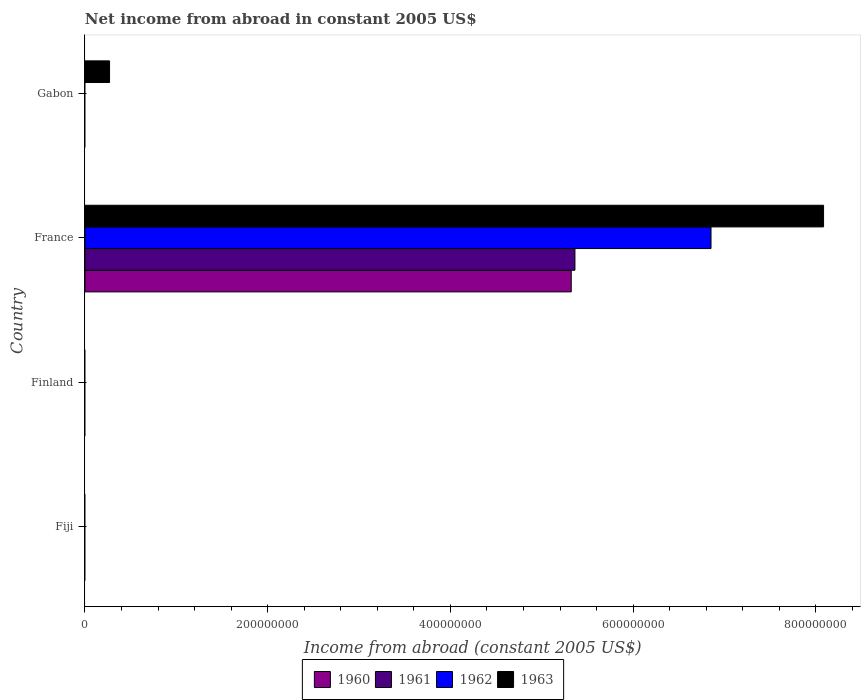Are the number of bars per tick equal to the number of legend labels?
Your answer should be compact. No. Are the number of bars on each tick of the Y-axis equal?
Keep it short and to the point. No. What is the label of the 1st group of bars from the top?
Provide a short and direct response. Gabon. In how many cases, is the number of bars for a given country not equal to the number of legend labels?
Offer a terse response. 3. What is the net income from abroad in 1962 in France?
Make the answer very short. 6.85e+08. Across all countries, what is the maximum net income from abroad in 1962?
Your response must be concise. 6.85e+08. Across all countries, what is the minimum net income from abroad in 1960?
Offer a very short reply. 0. What is the total net income from abroad in 1963 in the graph?
Provide a succinct answer. 8.35e+08. What is the difference between the net income from abroad in 1963 in France and that in Gabon?
Your answer should be compact. 7.81e+08. What is the difference between the net income from abroad in 1963 in Fiji and the net income from abroad in 1961 in Gabon?
Give a very brief answer. 0. What is the average net income from abroad in 1962 per country?
Provide a short and direct response. 1.71e+08. What is the difference between the net income from abroad in 1960 and net income from abroad in 1962 in France?
Provide a short and direct response. -1.53e+08. What is the difference between the highest and the lowest net income from abroad in 1963?
Give a very brief answer. 8.08e+08. Are all the bars in the graph horizontal?
Your answer should be compact. Yes. What is the difference between two consecutive major ticks on the X-axis?
Provide a succinct answer. 2.00e+08. Are the values on the major ticks of X-axis written in scientific E-notation?
Offer a very short reply. No. Does the graph contain grids?
Provide a short and direct response. No. Where does the legend appear in the graph?
Your response must be concise. Bottom center. How many legend labels are there?
Your answer should be compact. 4. How are the legend labels stacked?
Offer a terse response. Horizontal. What is the title of the graph?
Ensure brevity in your answer.  Net income from abroad in constant 2005 US$. Does "1991" appear as one of the legend labels in the graph?
Provide a short and direct response. No. What is the label or title of the X-axis?
Keep it short and to the point. Income from abroad (constant 2005 US$). What is the label or title of the Y-axis?
Your answer should be compact. Country. What is the Income from abroad (constant 2005 US$) in 1962 in Fiji?
Provide a short and direct response. 0. What is the Income from abroad (constant 2005 US$) of 1960 in Finland?
Provide a succinct answer. 0. What is the Income from abroad (constant 2005 US$) of 1961 in Finland?
Make the answer very short. 0. What is the Income from abroad (constant 2005 US$) of 1963 in Finland?
Provide a succinct answer. 0. What is the Income from abroad (constant 2005 US$) in 1960 in France?
Ensure brevity in your answer.  5.32e+08. What is the Income from abroad (constant 2005 US$) of 1961 in France?
Provide a short and direct response. 5.36e+08. What is the Income from abroad (constant 2005 US$) of 1962 in France?
Make the answer very short. 6.85e+08. What is the Income from abroad (constant 2005 US$) in 1963 in France?
Make the answer very short. 8.08e+08. What is the Income from abroad (constant 2005 US$) in 1960 in Gabon?
Offer a terse response. 0. What is the Income from abroad (constant 2005 US$) in 1962 in Gabon?
Ensure brevity in your answer.  0. What is the Income from abroad (constant 2005 US$) of 1963 in Gabon?
Provide a succinct answer. 2.69e+07. Across all countries, what is the maximum Income from abroad (constant 2005 US$) of 1960?
Your response must be concise. 5.32e+08. Across all countries, what is the maximum Income from abroad (constant 2005 US$) of 1961?
Give a very brief answer. 5.36e+08. Across all countries, what is the maximum Income from abroad (constant 2005 US$) in 1962?
Keep it short and to the point. 6.85e+08. Across all countries, what is the maximum Income from abroad (constant 2005 US$) of 1963?
Provide a short and direct response. 8.08e+08. Across all countries, what is the minimum Income from abroad (constant 2005 US$) in 1960?
Your answer should be compact. 0. What is the total Income from abroad (constant 2005 US$) in 1960 in the graph?
Your answer should be very brief. 5.32e+08. What is the total Income from abroad (constant 2005 US$) of 1961 in the graph?
Make the answer very short. 5.36e+08. What is the total Income from abroad (constant 2005 US$) of 1962 in the graph?
Offer a terse response. 6.85e+08. What is the total Income from abroad (constant 2005 US$) of 1963 in the graph?
Your response must be concise. 8.35e+08. What is the difference between the Income from abroad (constant 2005 US$) in 1963 in France and that in Gabon?
Offer a very short reply. 7.81e+08. What is the difference between the Income from abroad (constant 2005 US$) of 1960 in France and the Income from abroad (constant 2005 US$) of 1963 in Gabon?
Your answer should be very brief. 5.05e+08. What is the difference between the Income from abroad (constant 2005 US$) of 1961 in France and the Income from abroad (constant 2005 US$) of 1963 in Gabon?
Provide a succinct answer. 5.09e+08. What is the difference between the Income from abroad (constant 2005 US$) of 1962 in France and the Income from abroad (constant 2005 US$) of 1963 in Gabon?
Provide a succinct answer. 6.58e+08. What is the average Income from abroad (constant 2005 US$) in 1960 per country?
Offer a terse response. 1.33e+08. What is the average Income from abroad (constant 2005 US$) of 1961 per country?
Your answer should be very brief. 1.34e+08. What is the average Income from abroad (constant 2005 US$) of 1962 per country?
Provide a succinct answer. 1.71e+08. What is the average Income from abroad (constant 2005 US$) of 1963 per country?
Make the answer very short. 2.09e+08. What is the difference between the Income from abroad (constant 2005 US$) of 1960 and Income from abroad (constant 2005 US$) of 1961 in France?
Your answer should be very brief. -4.05e+06. What is the difference between the Income from abroad (constant 2005 US$) in 1960 and Income from abroad (constant 2005 US$) in 1962 in France?
Your answer should be compact. -1.53e+08. What is the difference between the Income from abroad (constant 2005 US$) in 1960 and Income from abroad (constant 2005 US$) in 1963 in France?
Make the answer very short. -2.76e+08. What is the difference between the Income from abroad (constant 2005 US$) of 1961 and Income from abroad (constant 2005 US$) of 1962 in France?
Ensure brevity in your answer.  -1.49e+08. What is the difference between the Income from abroad (constant 2005 US$) of 1961 and Income from abroad (constant 2005 US$) of 1963 in France?
Make the answer very short. -2.72e+08. What is the difference between the Income from abroad (constant 2005 US$) of 1962 and Income from abroad (constant 2005 US$) of 1963 in France?
Your answer should be compact. -1.23e+08. What is the ratio of the Income from abroad (constant 2005 US$) in 1963 in France to that in Gabon?
Offer a terse response. 30.04. What is the difference between the highest and the lowest Income from abroad (constant 2005 US$) of 1960?
Ensure brevity in your answer.  5.32e+08. What is the difference between the highest and the lowest Income from abroad (constant 2005 US$) in 1961?
Ensure brevity in your answer.  5.36e+08. What is the difference between the highest and the lowest Income from abroad (constant 2005 US$) of 1962?
Your answer should be compact. 6.85e+08. What is the difference between the highest and the lowest Income from abroad (constant 2005 US$) in 1963?
Your answer should be compact. 8.08e+08. 